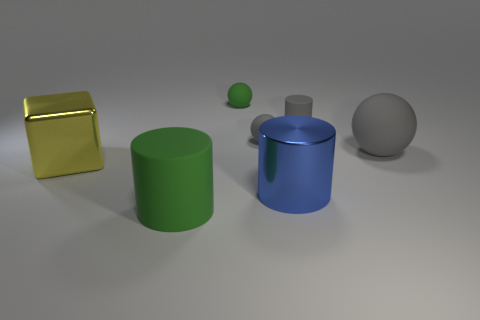What number of other things are there of the same size as the green rubber cylinder?
Keep it short and to the point. 3. There is a matte cylinder that is behind the yellow metallic cube; how big is it?
Your answer should be compact. Small. There is a big gray thing that is made of the same material as the gray cylinder; what shape is it?
Provide a short and direct response. Sphere. Is there anything else of the same color as the large sphere?
Your answer should be compact. Yes. There is a shiny thing that is behind the large cylinder behind the large green cylinder; what color is it?
Keep it short and to the point. Yellow. How many big objects are either rubber objects or metallic objects?
Your response must be concise. 4. What material is the small gray thing that is the same shape as the big gray object?
Offer a terse response. Rubber. Is there anything else that has the same material as the gray cylinder?
Provide a succinct answer. Yes. The large matte cylinder is what color?
Your answer should be very brief. Green. Do the block and the large sphere have the same color?
Provide a short and direct response. No. 